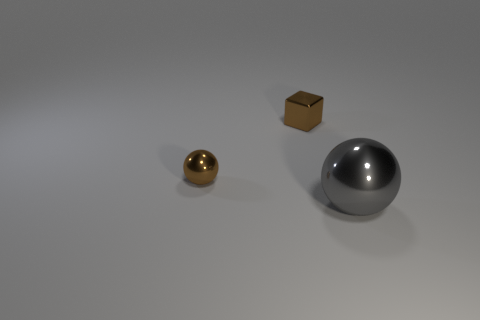Add 3 large gray shiny balls. How many objects exist? 6 Subtract all blocks. How many objects are left? 2 Add 1 brown shiny objects. How many brown shiny objects exist? 3 Subtract 0 purple blocks. How many objects are left? 3 Subtract all large green metal blocks. Subtract all metallic balls. How many objects are left? 1 Add 1 small brown balls. How many small brown balls are left? 2 